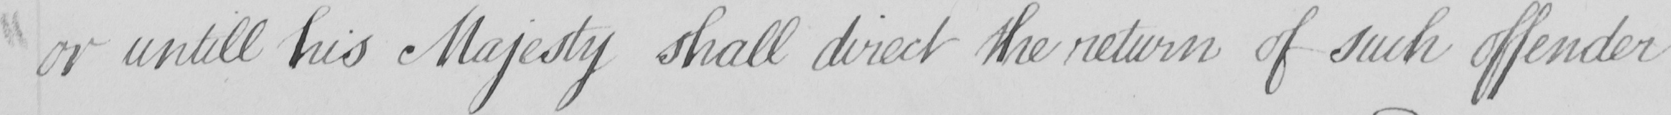Can you tell me what this handwritten text says? or untill his Majesty shall direct the return of such offender 